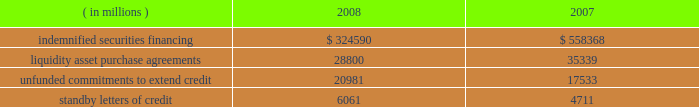The table summarizes the total contractual amount of credit-related , off-balance sheet financial instruments at december 31 .
Amounts reported do not reflect participations to independent third parties. .
Approximately 81% ( 81 % ) of the unfunded commitments to extend credit expire within one year from the date of issue .
Since many of the commitments are expected to expire or renew without being drawn upon , the total commitment amounts do not necessarily represent future cash requirements .
Securities finance : on behalf of our customers , we lend their securities to creditworthy brokers and other institutions .
We generally indemnify our customers for the fair market value of those securities against a failure of the borrower to return such securities .
Collateral funds received in connection with our securities finance services are held by us as agent and are not recorded in our consolidated statement of condition .
We require the borrowers to provide collateral in an amount equal to or in excess of 100% ( 100 % ) of the fair market value of the securities borrowed .
The borrowed securities are revalued daily to determine if additional collateral is necessary .
In this regard , we held , as agent , cash and u.s .
Government securities with an aggregate fair value of $ 333.07 billion and $ 572.93 billion as collateral for indemnified securities on loan at december 31 , 2008 and 2007 , respectively , presented in the table above .
The collateral held by us is invested on behalf of our customers .
In certain cases , the collateral is invested in third-party repurchase agreements , for which we indemnify the customer against loss of the principal invested .
We require the repurchase agreement counterparty to provide collateral in an amount equal to or in excess of 100% ( 100 % ) of the amount of the repurchase agreement .
The indemnified repurchase agreements and the related collateral are not recorded in our consolidated statement of condition .
Of the collateral of $ 333.07 billion at december 31 , 2008 and $ 572.93 billion at december 31 , 2007 referenced above , $ 68.37 billion at december 31 , 2008 and $ 106.13 billion at december 31 , 2007 was invested in indemnified repurchase agreements .
We held , as agent , cash and securities with an aggregate fair value of $ 71.87 billion and $ 111.02 billion as collateral for indemnified investments in repurchase agreements at december 31 , 2008 and december 31 , 2007 , respectively .
Asset-backed commercial paper program : in the normal course of our business , we provide liquidity and credit enhancement to an asset-backed commercial paper program sponsored and administered by us , described in note 12 .
The commercial paper issuances and commitments of the commercial paper conduits to provide funding are supported by liquidity asset purchase agreements and back-up liquidity lines of credit , the majority of which are provided by us .
In addition , we provide direct credit support to the conduits in the form of standby letters of credit .
Our commitments under liquidity asset purchase agreements and back-up lines of credit totaled $ 23.59 billion at december 31 , 2008 , and are included in the preceding table .
Our commitments under standby letters of credit totaled $ 1.00 billion at december 31 , 2008 , and are also included in the preceding table .
Legal proceedings : several customers have filed litigation claims against us , some of which are putative class actions purportedly on behalf of customers invested in certain of state street global advisors 2019 , or ssga 2019s , active fixed-income strategies .
These claims related to investment losses in one or more of ssga 2019s strategies that included sub-prime investments .
In 2007 , we established a reserve of approximately $ 625 million to address legal exposure associated with the under-performance of certain active fixed-income strategies managed by ssga and customer concerns as to whether the execution of these strategies was consistent with the customers 2019 investment intent .
These strategies were adversely impacted by exposure to , and the lack of liquidity in .
What portion of the 2008 collateral was invested in indemnified repurchase agreements in 2008? 
Computations: (68.37 / 333.07)
Answer: 0.20527. 